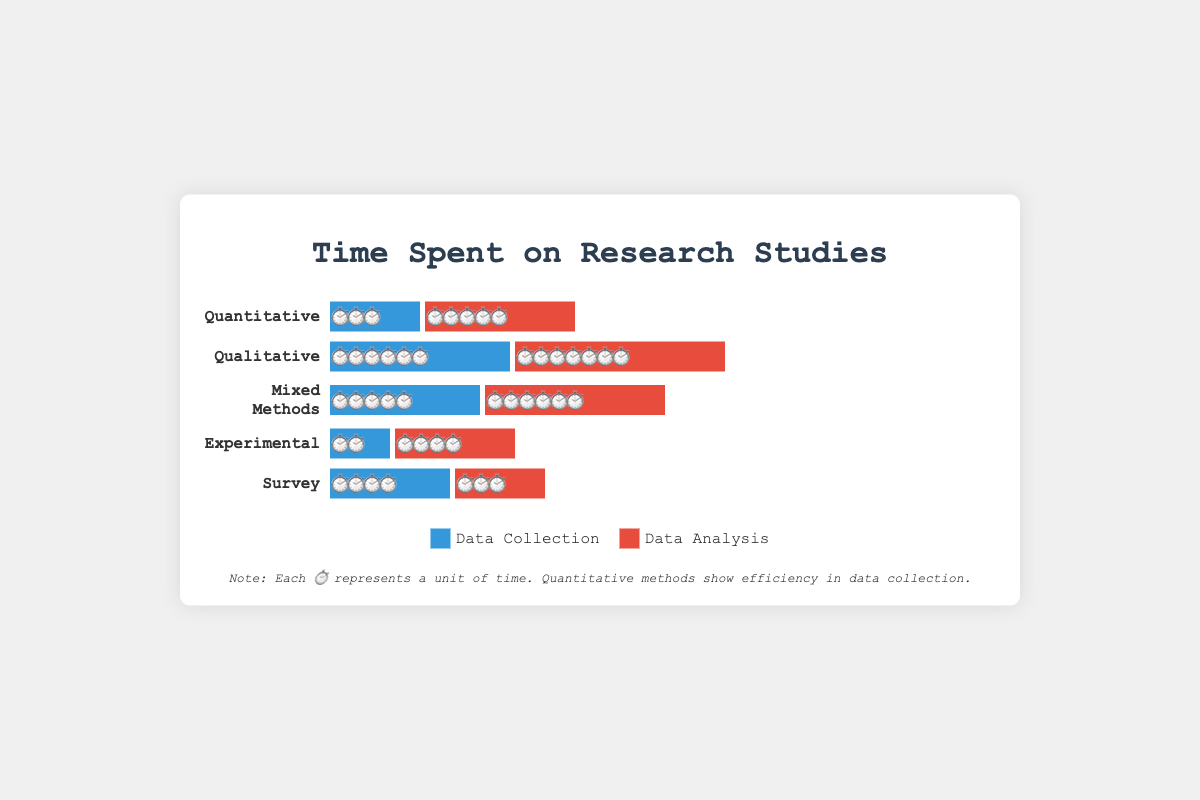Which type of study spends the most time on data collection? To find the type of study that spends the most time on data collection, compare the length of the blue bars (data collection) across all study types. Qualitative has the longest blue bar indicating 6 units of time.
Answer: Qualitative Which type of study spends the least time on data collection? To determine which study spends the least time on data collection, look for the shortest blue bar across all types of studies. Experimental has the shortest blue bar indicating 2 units of time.
Answer: Experimental Which study type has the largest difference between time spent on data collection and data analysis? Calculate the difference in time units between data collection (blue bar) and data analysis (red bar) for each study. Qualitative has the largest difference, with data collection at 6 units and data analysis at 7 units, resulting in a difference of 1 unit.
Answer: Qualitative Which study type has a balanced time allocation for data collection and analysis? To identify a balanced time allocation, compare the lengths of the blue (data collection) and red (data analysis) bars and look for similar lengths. Mixed Methods has similar lengths with 5 units for data collection and 6 units for data analysis.
Answer: Mixed Methods How much total time is spent on data collection for Quantitative and Experimental studies combined? Find and sum the data collection time units for Quantitative and Experimental studies. Quantitative has 3 units and Experimental has 2 units, summing up to 5 units.
Answer: 5 units Which type of study spends more time on data analysis: Survey or Experimental? Compare the lengths of the red bars (data analysis) for Survey and Experimental studies. Experimental has 4 units, while Survey has 3 units.
Answer: Experimental Calculate the average time spent on data analysis for all study types. Sum up the data analysis time units and divide by the number of study types. (5 + 7 + 6 + 4 + 3) / 5 = 25 / 5 = 5 units.
Answer: 5 units Which study type has a greater combined time spent on data collection and analysis: Quantitative or Mixed Methods? Calculate the total time (data collection + data analysis) for Quantitative and Mixed Methods. Quantitative totals 8 units (3 + 5), Mixed Methods totals 11 units (5 + 6).
Answer: Mixed Methods How does the time spent on data collection for Survey compare with that for Quantitative studies? Compare the lengths of the blue bars (data collection) for Survey and Quantitative studies. Survey has 4 units and Quantitative has 3 units.
Answer: Survey spends more What is the difference in total time (data collection + data analysis) between the Qualitative and Survey studies? Calculate total time for each: Qualitative (6 + 7 = 13 units), Survey (4 + 3 = 7 units). The difference is 13 - 7 = 6 units.
Answer: 6 units 